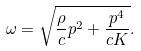<formula> <loc_0><loc_0><loc_500><loc_500>\omega = \sqrt { \frac { \rho } { c } p ^ { 2 } + \frac { p ^ { 4 } } { c K } } .</formula> 